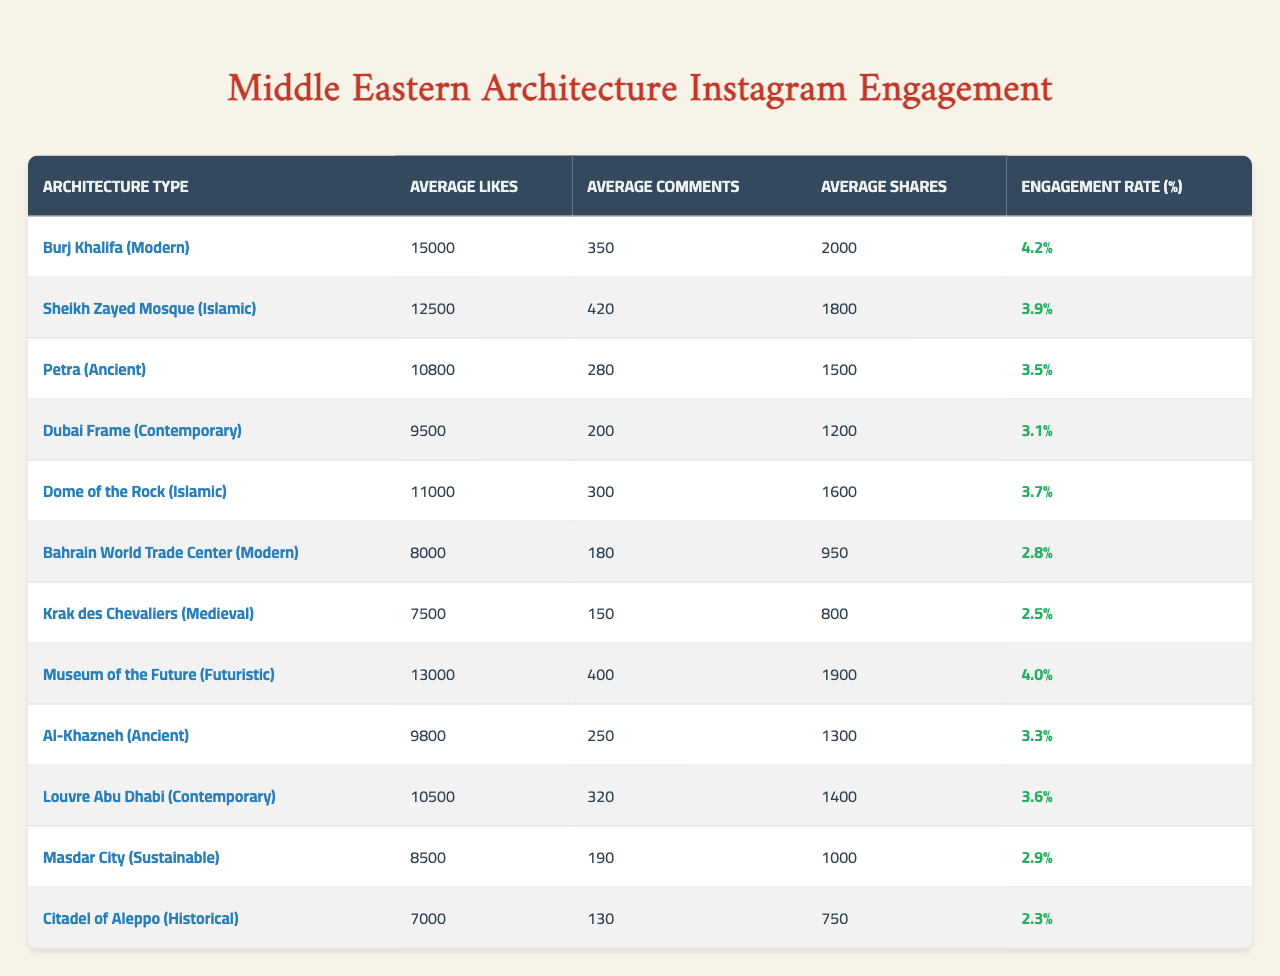What is the architecture type with the highest average likes? By inspecting the table, we find that the Burj Khalifa (Modern) has the highest average likes at 15,000.
Answer: Burj Khalifa (Modern) What is the engagement rate for the Sheikh Zayed Mosque (Islamic)? The engagement rate for the Sheikh Zayed Mosque (Islamic) is 3.9%, as shown in the table.
Answer: 3.9% Which architecture type has the lowest average shares? By reviewing the table, we see that the Bahrain World Trade Center (Modern) has the lowest average shares at 950.
Answer: Bahrain World Trade Center (Modern) True or False: The average number of comments for Petra (Ancient) is greater than that for the Dome of the Rock (Islamic). The average comments for Petra (Ancient) is 280, while for the Dome of the Rock (Islamic) it is 300. Thus, the statement is false.
Answer: False What is the average engagement rate of all the architecture types listed? To find the average engagement rate, we sum all engagement rates (4.2 + 3.9 + 3.5 + 3.1 + 3.7 + 2.8 + 2.5 + 4.0 + 3.3 + 3.6 + 2.9 + 2.3) = 43.8. There are 12 types, so the average is 43.8 / 12 = 3.65%.
Answer: 3.65% Which type of architecture has both a higher average likes than 10,000 and an engagement rate greater than 3.5%? By checking the criteria, the Burj Khalifa (Modern) and the Museum of the Future (Futuristic) meet both conditions—Burj Khalifa has 15,000 likes and 4.2% engagement, while Museum of the Future has 13,000 likes and 4.0% engagement.
Answer: Burj Khalifa (Modern), Museum of the Future (Futuristic) What is the difference in average likes between the highest and lowest architecture types? The highest average likes is from Burj Khalifa (Modern) at 15,000, and the lowest is from the Citadel of Aleppo (Historical) at 7,000. Therefore, the difference is 15,000 - 7,000 = 8,000.
Answer: 8000 Which architecture type has an average number of comments of at least 300 and an engagement rate below 4%? The Dome of the Rock (Islamic) has 300 comments and an engagement rate of 3.7%, while the Dubai Frame (Contemporary) has 200 comments but does not meet the comment criteria. The Dome of the Rock is the only one that meets the requirements.
Answer: Dome of the Rock (Islamic) 